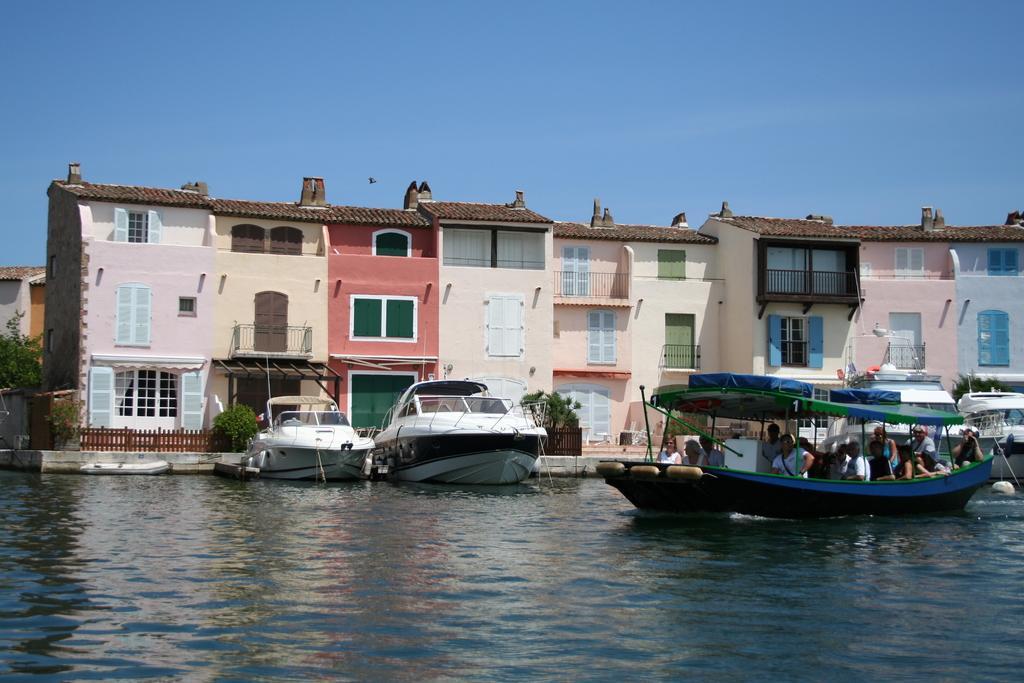Describe this image in one or two sentences. On the right we can see group of persons sitting on the boat. Here we can see two boards which is near to the wooden fencing and plants. On the background we can see buildings. On the top there is a sky. On the bottom we can see water. 